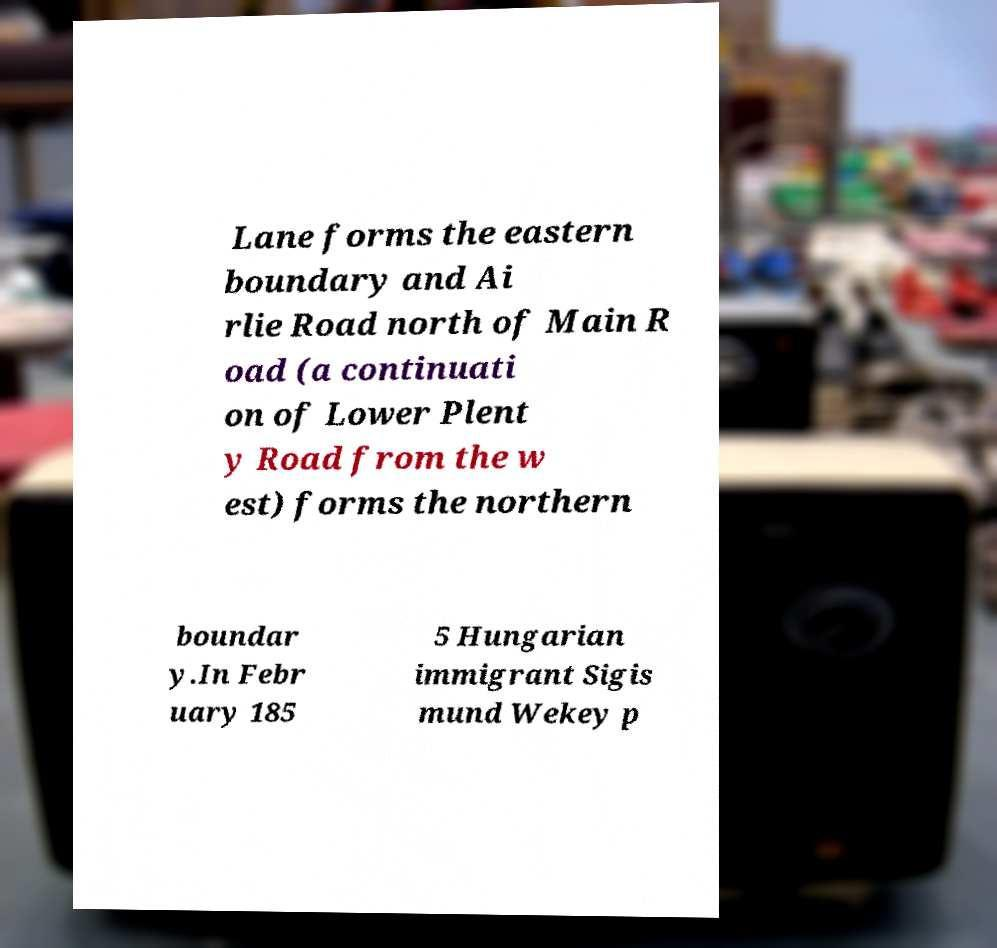Can you read and provide the text displayed in the image?This photo seems to have some interesting text. Can you extract and type it out for me? Lane forms the eastern boundary and Ai rlie Road north of Main R oad (a continuati on of Lower Plent y Road from the w est) forms the northern boundar y.In Febr uary 185 5 Hungarian immigrant Sigis mund Wekey p 